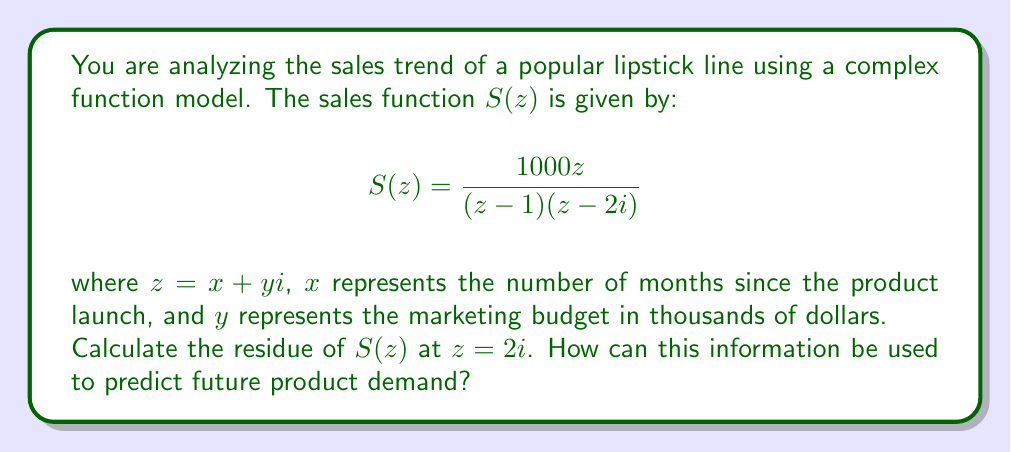Give your solution to this math problem. To solve this problem, we'll follow these steps:

1) The residue of a function $f(z)$ at a simple pole $z = a$ is given by:

   $$\text{Res}(f, a) = \lim_{z \to a} (z-a)f(z)$$

2) In our case, $z = 2i$ is a simple pole of $S(z)$. Let's calculate the residue:

   $$\text{Res}(S, 2i) = \lim_{z \to 2i} (z-2i)\frac{1000z}{(z-1)(z-2i)}$$

3) Simplify:

   $$\text{Res}(S, 2i) = \lim_{z \to 2i} \frac{1000z}{z-1}$$

4) Substitute $z = 2i$:

   $$\text{Res}(S, 2i) = \frac{1000(2i)}{2i-1} = \frac{2000i}{2i-1}$$

5) Multiply numerator and denominator by the complex conjugate of the denominator:

   $$\text{Res}(S, 2i) = \frac{2000i(2i+1)}{(2i-1)(2i+1)} = \frac{2000i(2i+1)}{4i^2+1} = \frac{2000i(2i+1)}{-3}$$

6) Simplify:

   $$\text{Res}(S, 2i) = \frac{-4000+2000i}{-3} = \frac{4000-2000i}{3}$$

The residue provides information about the behavior of the function near the pole. In this context:

- The real part (4000/3) suggests the base level of demand when marketing budget is around $2000.
- The imaginary part (-2000i/3) indicates how sensitive the demand is to changes in marketing budget at this point.

This information can be used to predict future product demand by:
1) Estimating the baseline demand for the product.
2) Understanding how changes in marketing budget affect demand.
3) Identifying potential instabilities or rapid changes in demand around certain marketing budget levels.
4) Optimizing marketing strategies based on the relationship between time since launch and marketing budget.
Answer: The residue of $S(z)$ at $z = 2i$ is $\frac{4000-2000i}{3}$. 